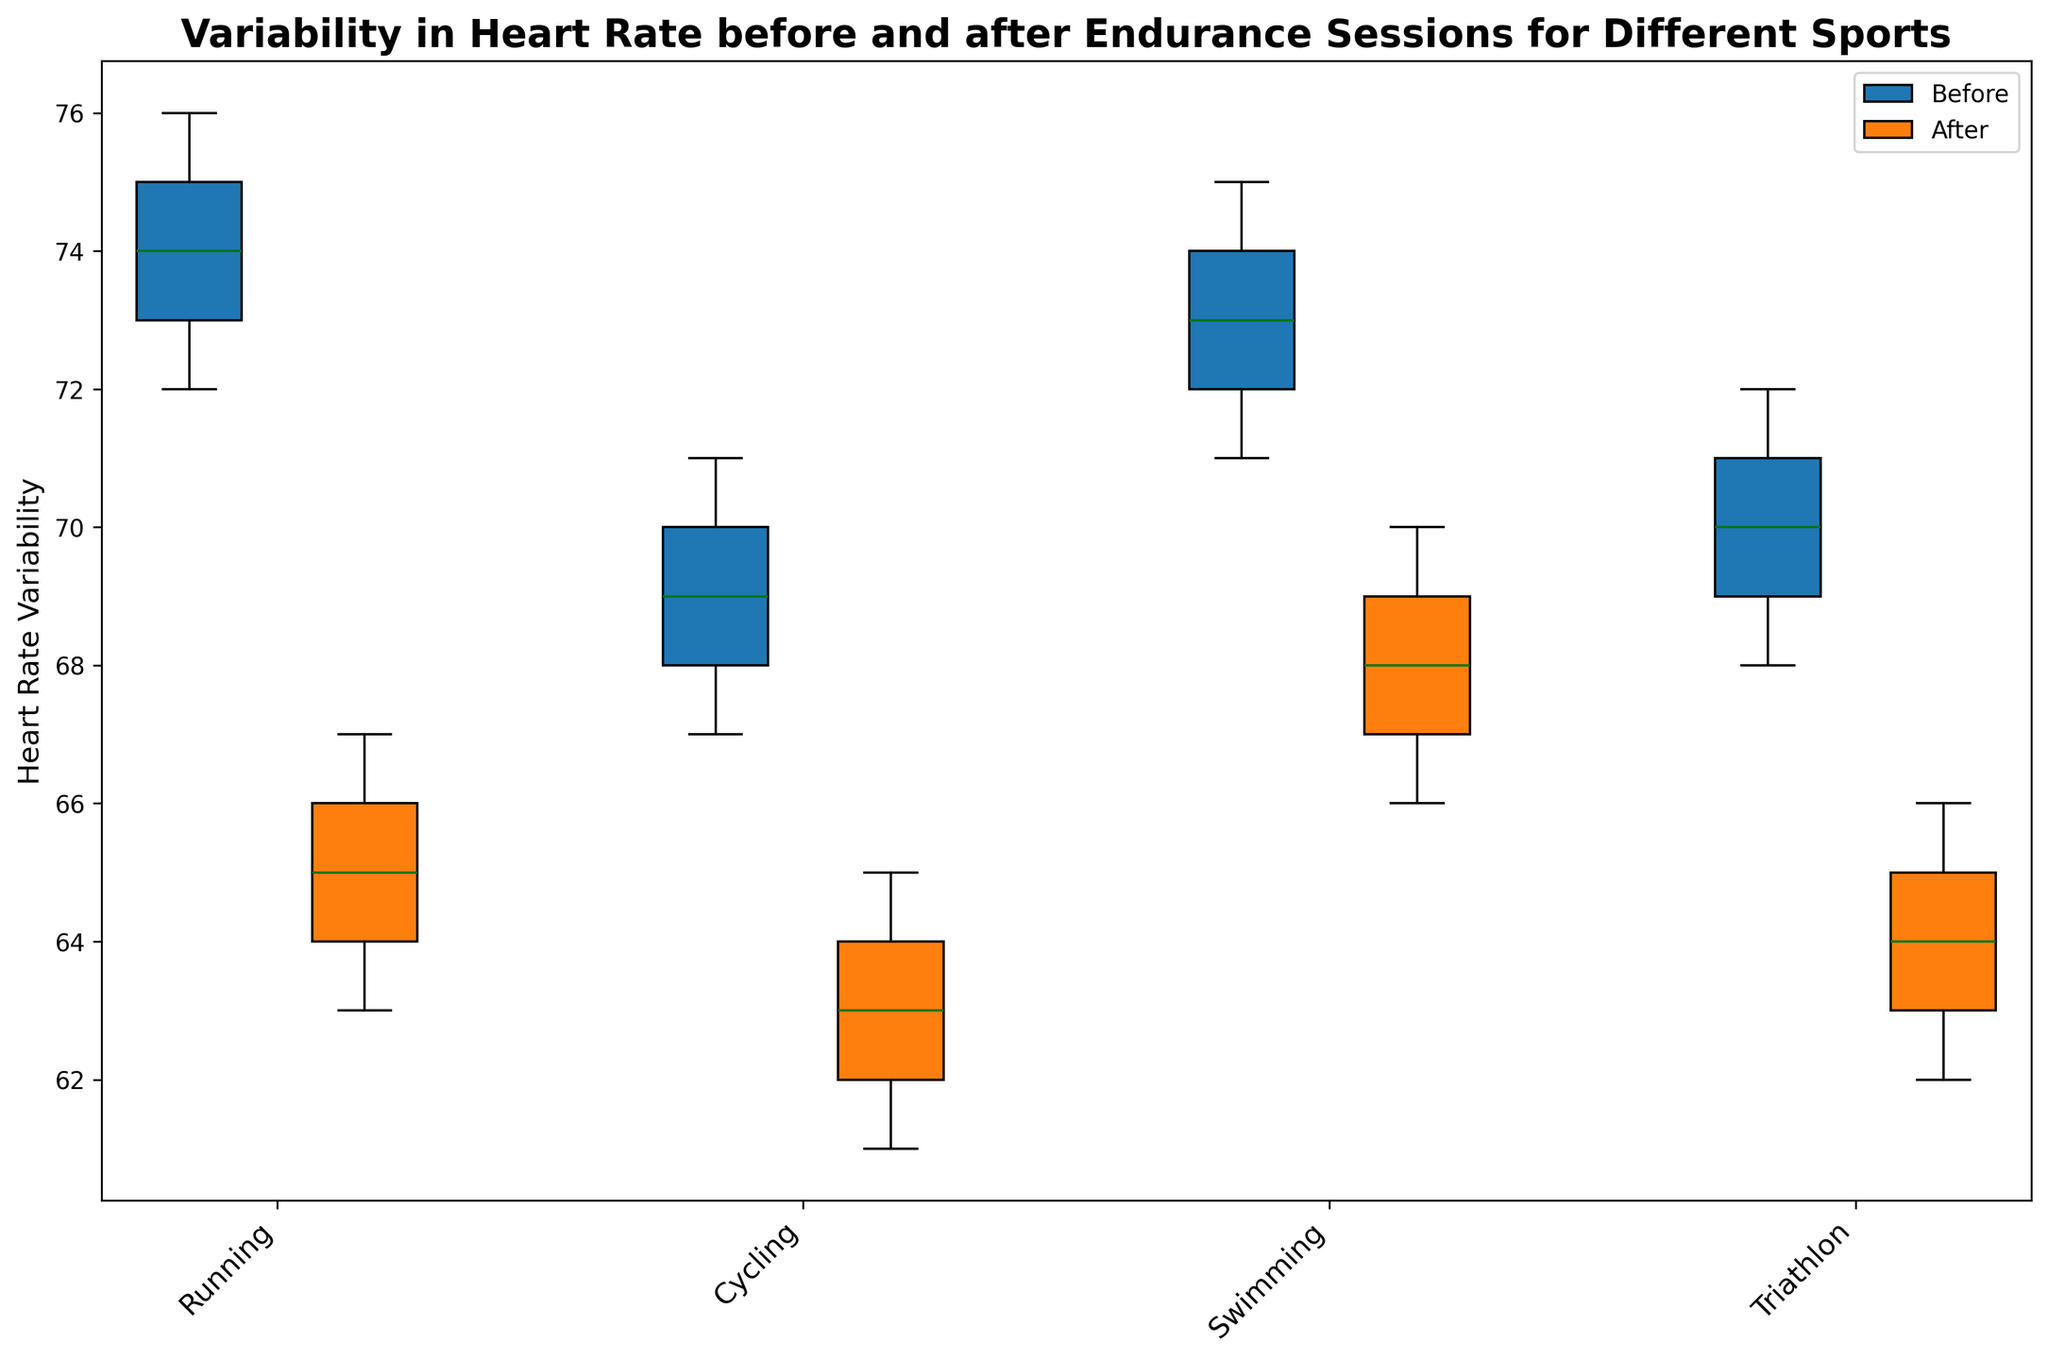What sport shows the greatest decrease in heart rate variability after the endurance sessions? To determine which sport shows the greatest decrease in heart rate variability after the sessions, look at the difference in median values of the box plots before and after for each sport. The sport with the largest difference is the one with the greatest decrease.
Answer: Running Which sport has the highest median heart rate variability before the endurance sessions? To find this, compare the median lines (usually the line inside the box) of the 'Before' box plots across all sports. The highest median would be the sport you are looking for.
Answer: Running How does the median heart rate variability before the session for Triathlon compare to Cycling? Check the median values of the 'Before' box plots for both Triathlon and Cycling. Compare these two median values directly.
Answer: Triathlon is higher What is the general trend in heart rate variability after endurance sessions across all sports? Examine the position of the median lines in the 'Before' and 'After' box plots for all sports. Notice if they generally increase, decrease, or stay the same.
Answer: Decrease Which sport has the least variability in heart rate before the endurance sessions? Look at the box plot widths (whiskers) for the 'Before' condition for each sport. The narrowest box plot indicates the least variability.
Answer: Cycling How does the interquartile range (IQR) of heart rate variability for Swimming before the session compare to that of Swimming after the session? IQR is indicated by the height of the box in the box plot. Compare the height of the box before and after for Swimming.
Answer: Lower after Does any sport have overlapping 'Before' and 'After' heart rate variability ranges? Check if the whiskers (lines indicating range) of 'Before' and 'After' box plots overlap for any sport.
Answer: Yes, Swimming What is the rank order of sports based on median heart rate variability after the session from highest to lowest? Identify and list the median values (middle line in the box) of the 'After' box plots for all sports, then arrange these median values in descending order.
Answer: Swimming, Triathlon, Cycling, Running 